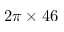<formula> <loc_0><loc_0><loc_500><loc_500>2 \pi \times 4 6</formula> 